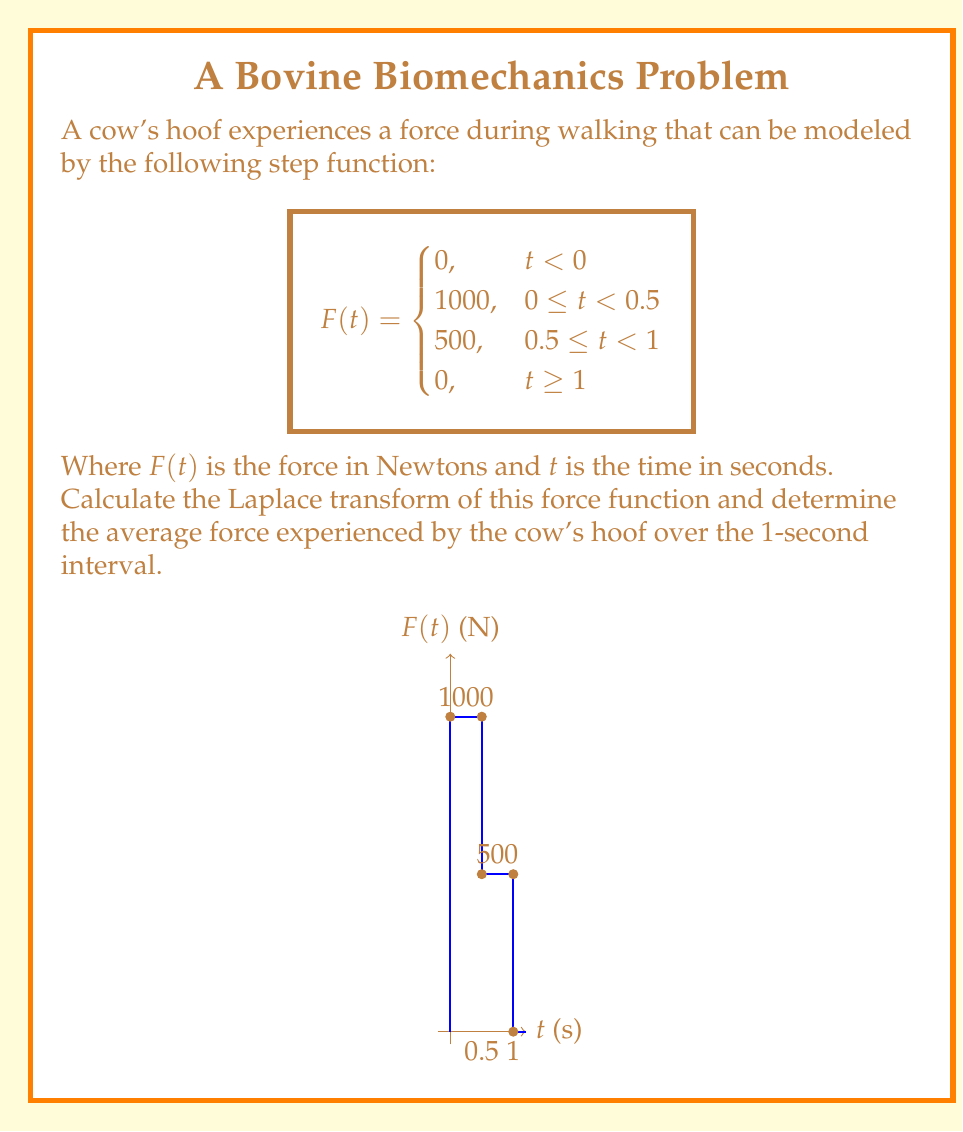Can you answer this question? Let's approach this step-by-step:

1) First, we need to express the force function using unit step functions:

   $$F(t) = 1000[u(t) - u(t-0.5)] + 500[u(t-0.5) - u(t-1)]$$

   Where $u(t)$ is the unit step function.

2) Now, let's take the Laplace transform. We'll use the property:

   $$\mathcal{L}\{u(t-a)f(t-a)\} = e^{-as}\mathcal{L}\{f(t)\}$$

3) Applying the Laplace transform:

   $$\mathcal{L}\{F(t)\} = 1000\mathcal{L}\{u(t) - u(t-0.5)\} + 500\mathcal{L}\{u(t-0.5) - u(t-1)\}$$

   $$= 1000(\frac{1}{s} - \frac{e^{-0.5s}}{s}) + 500(\frac{e^{-0.5s}}{s} - \frac{e^{-s}}{s})$$

   $$= \frac{1000}{s} - \frac{1000e^{-0.5s}}{s} + \frac{500e^{-0.5s}}{s} - \frac{500e^{-s}}{s}$$

   $$= \frac{1000 - 1000e^{-0.5s} + 500e^{-0.5s} - 500e^{-s}}{s}$$

   $$= \frac{1000 - 500e^{-0.5s} - 500e^{-s}}{s}$$

4) To find the average force, we can use the Final Value Theorem:

   $$\lim_{t \to \infty} \frac{1}{t}\int_0^t F(\tau)d\tau = \lim_{s \to 0} s\mathcal{L}\{F(t)\}$$

5) Applying this to our Laplace transform:

   $$\text{Average Force} = \lim_{s \to 0} (1000 - 500e^{-0.5s} - 500e^{-s})$$

   $$= 1000 - 500 - 500 = 0$$

6) However, this result is for $t \to \infty$. For the 1-second interval, we need to calculate:

   $$\text{Average Force} = \frac{1}{1}\int_0^1 F(t)dt = 1000 \cdot 0.5 + 500 \cdot 0.5 = 750 \text{ N}$$
Answer: $\mathcal{L}\{F(t)\} = \frac{1000 - 500e^{-0.5s} - 500e^{-s}}{s}$; Average force = 750 N 